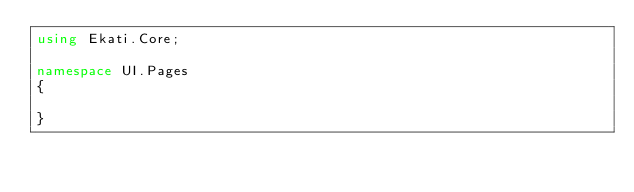Convert code to text. <code><loc_0><loc_0><loc_500><loc_500><_C#_>using Ekati.Core;

namespace UI.Pages
{
    
}</code> 